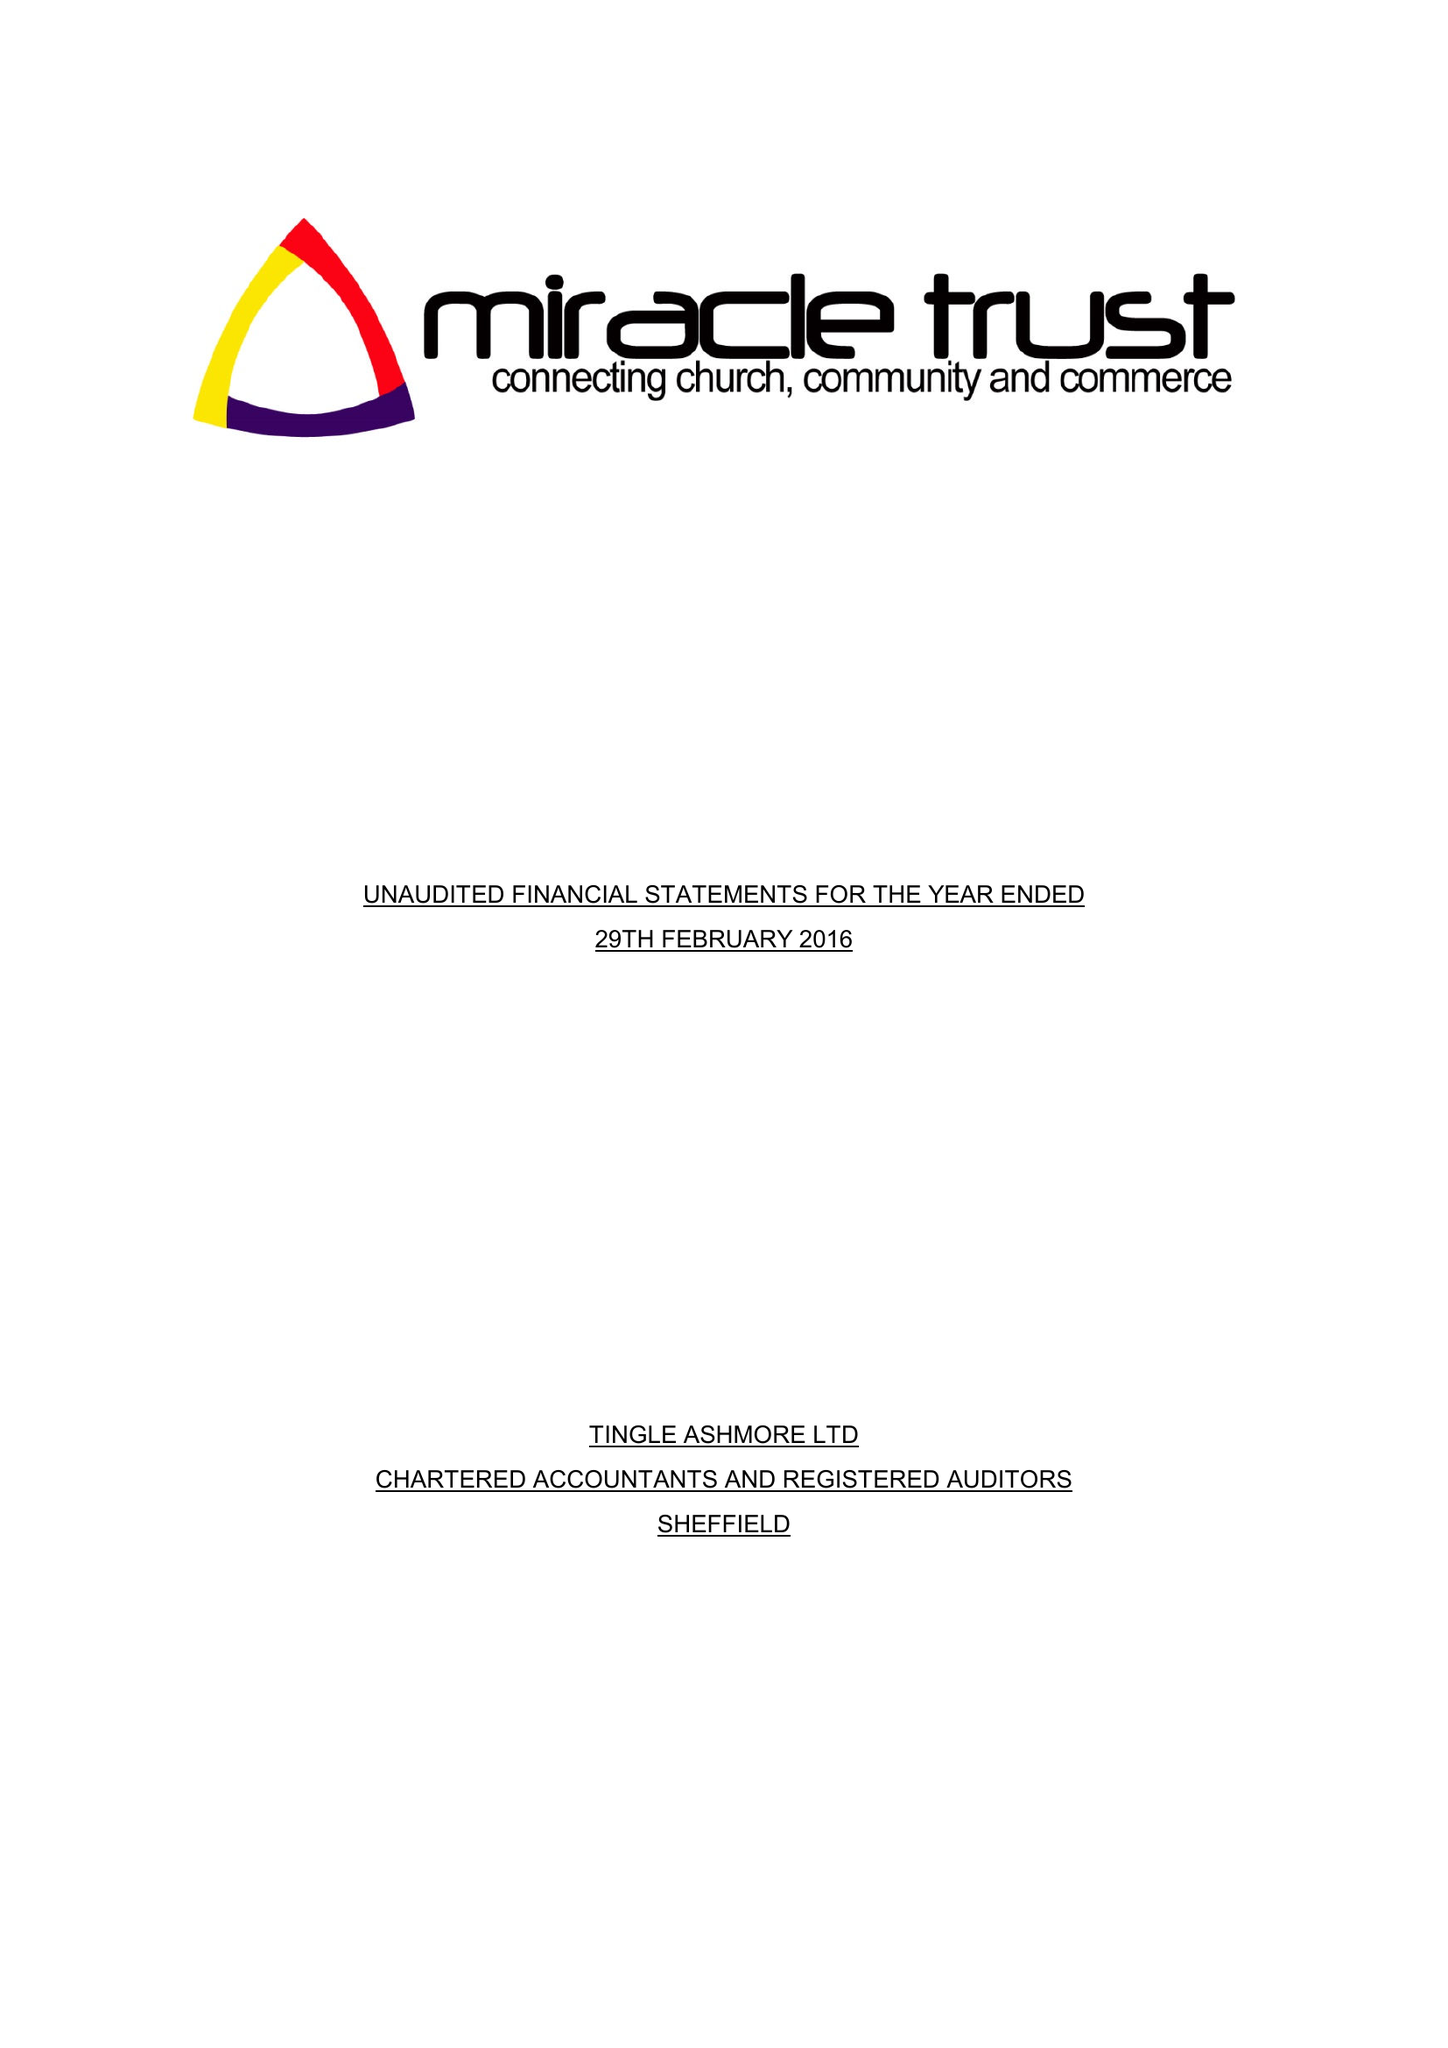What is the value for the address__post_town?
Answer the question using a single word or phrase. SHEFFIELD 